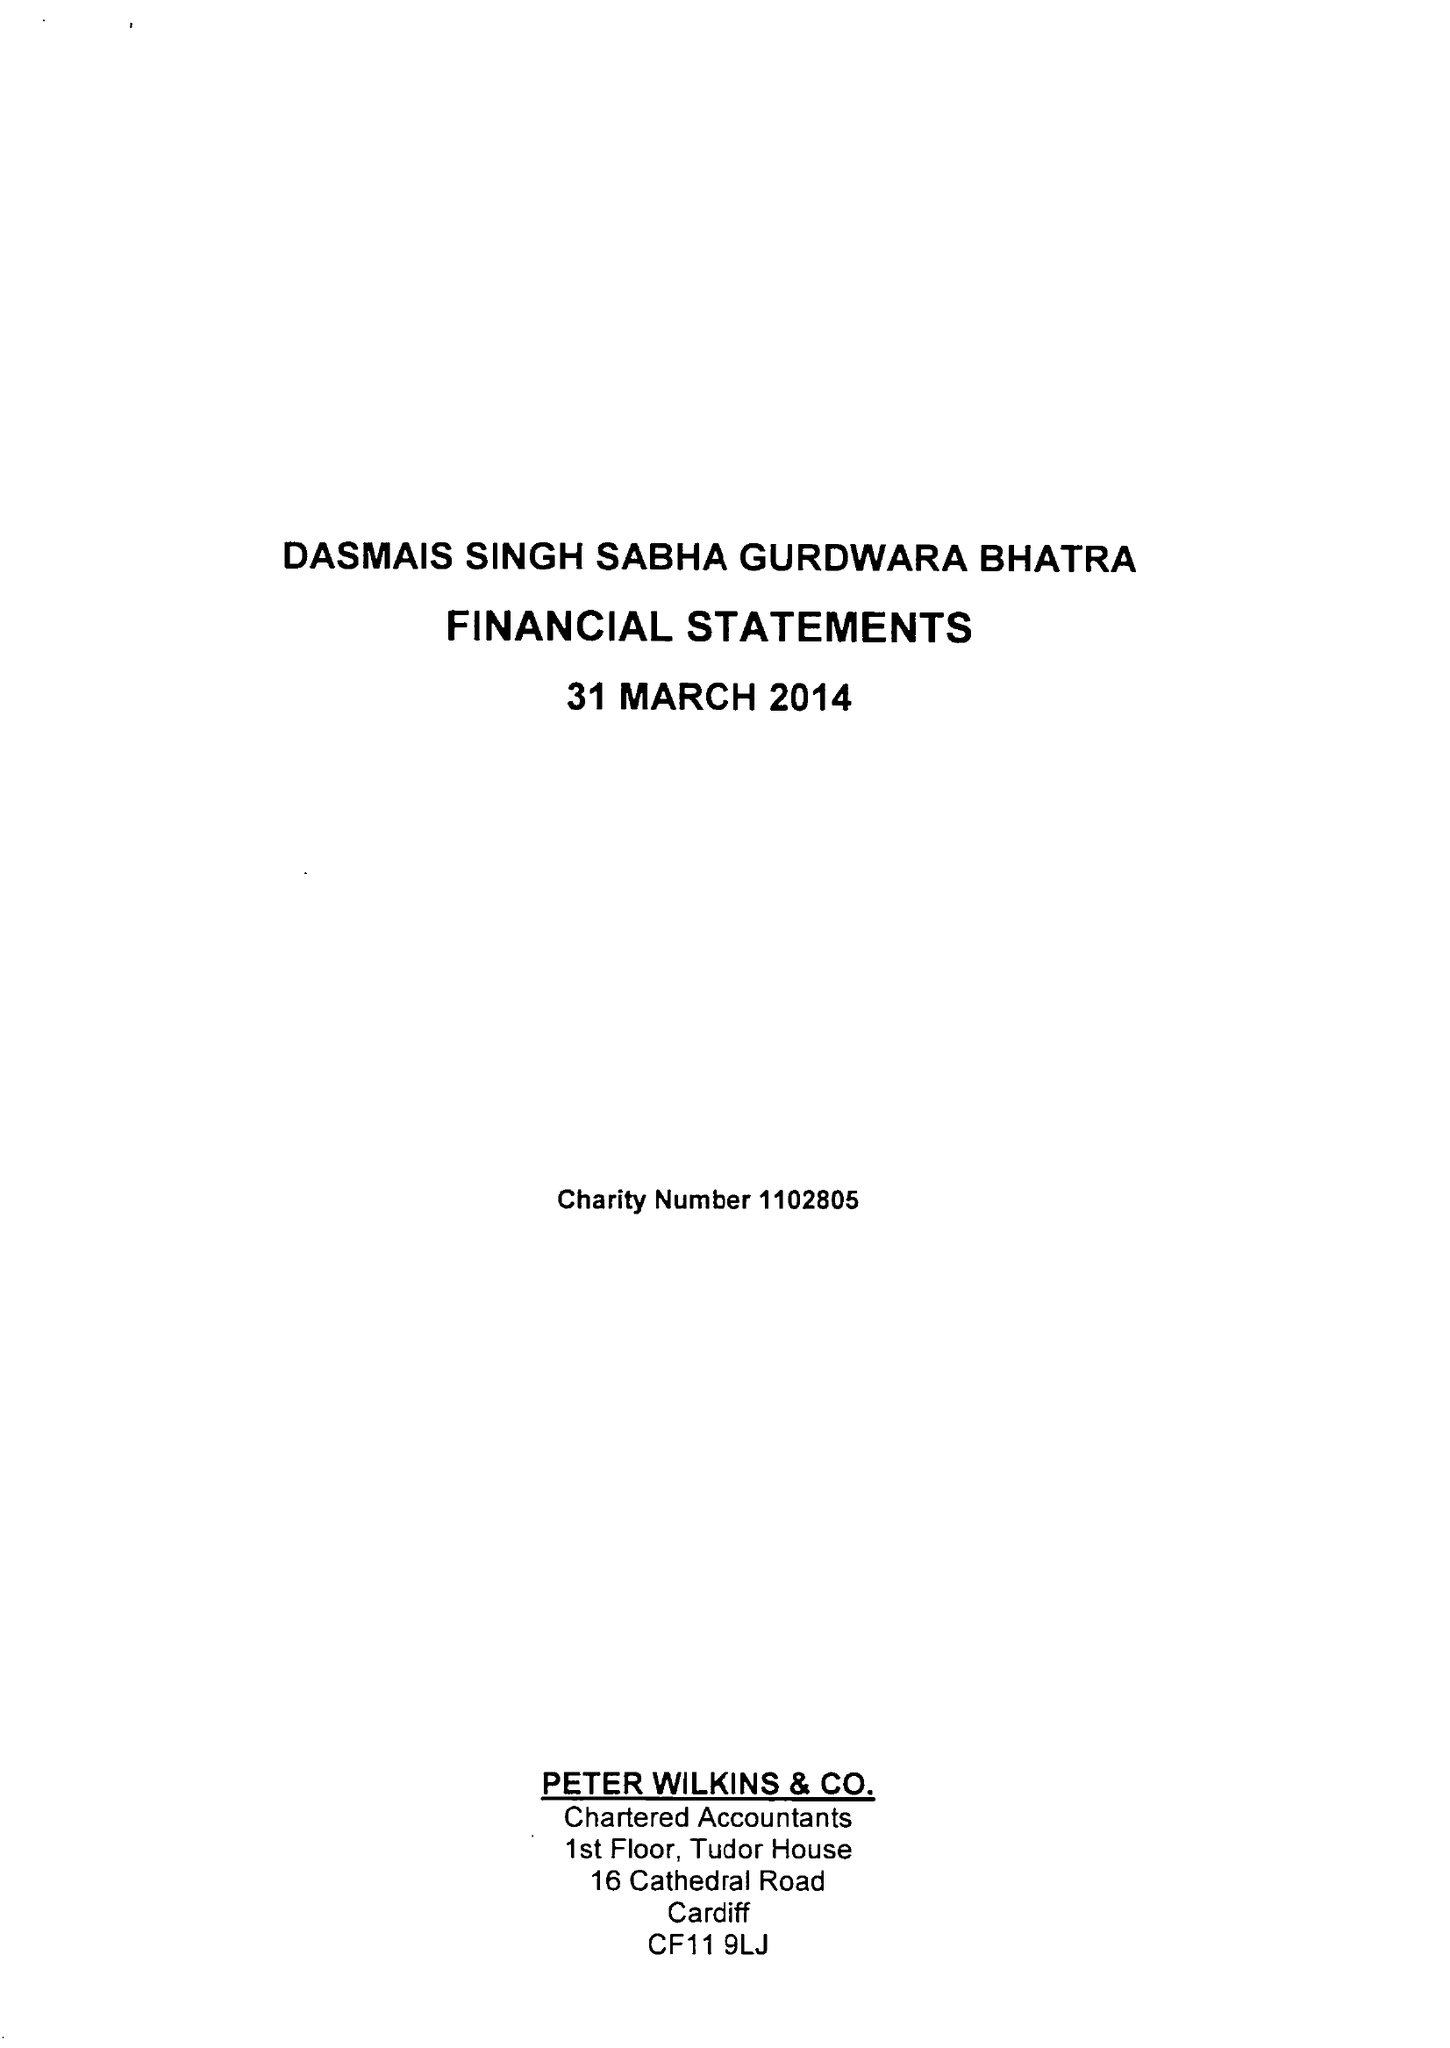What is the value for the charity_number?
Answer the question using a single word or phrase. 1102805 